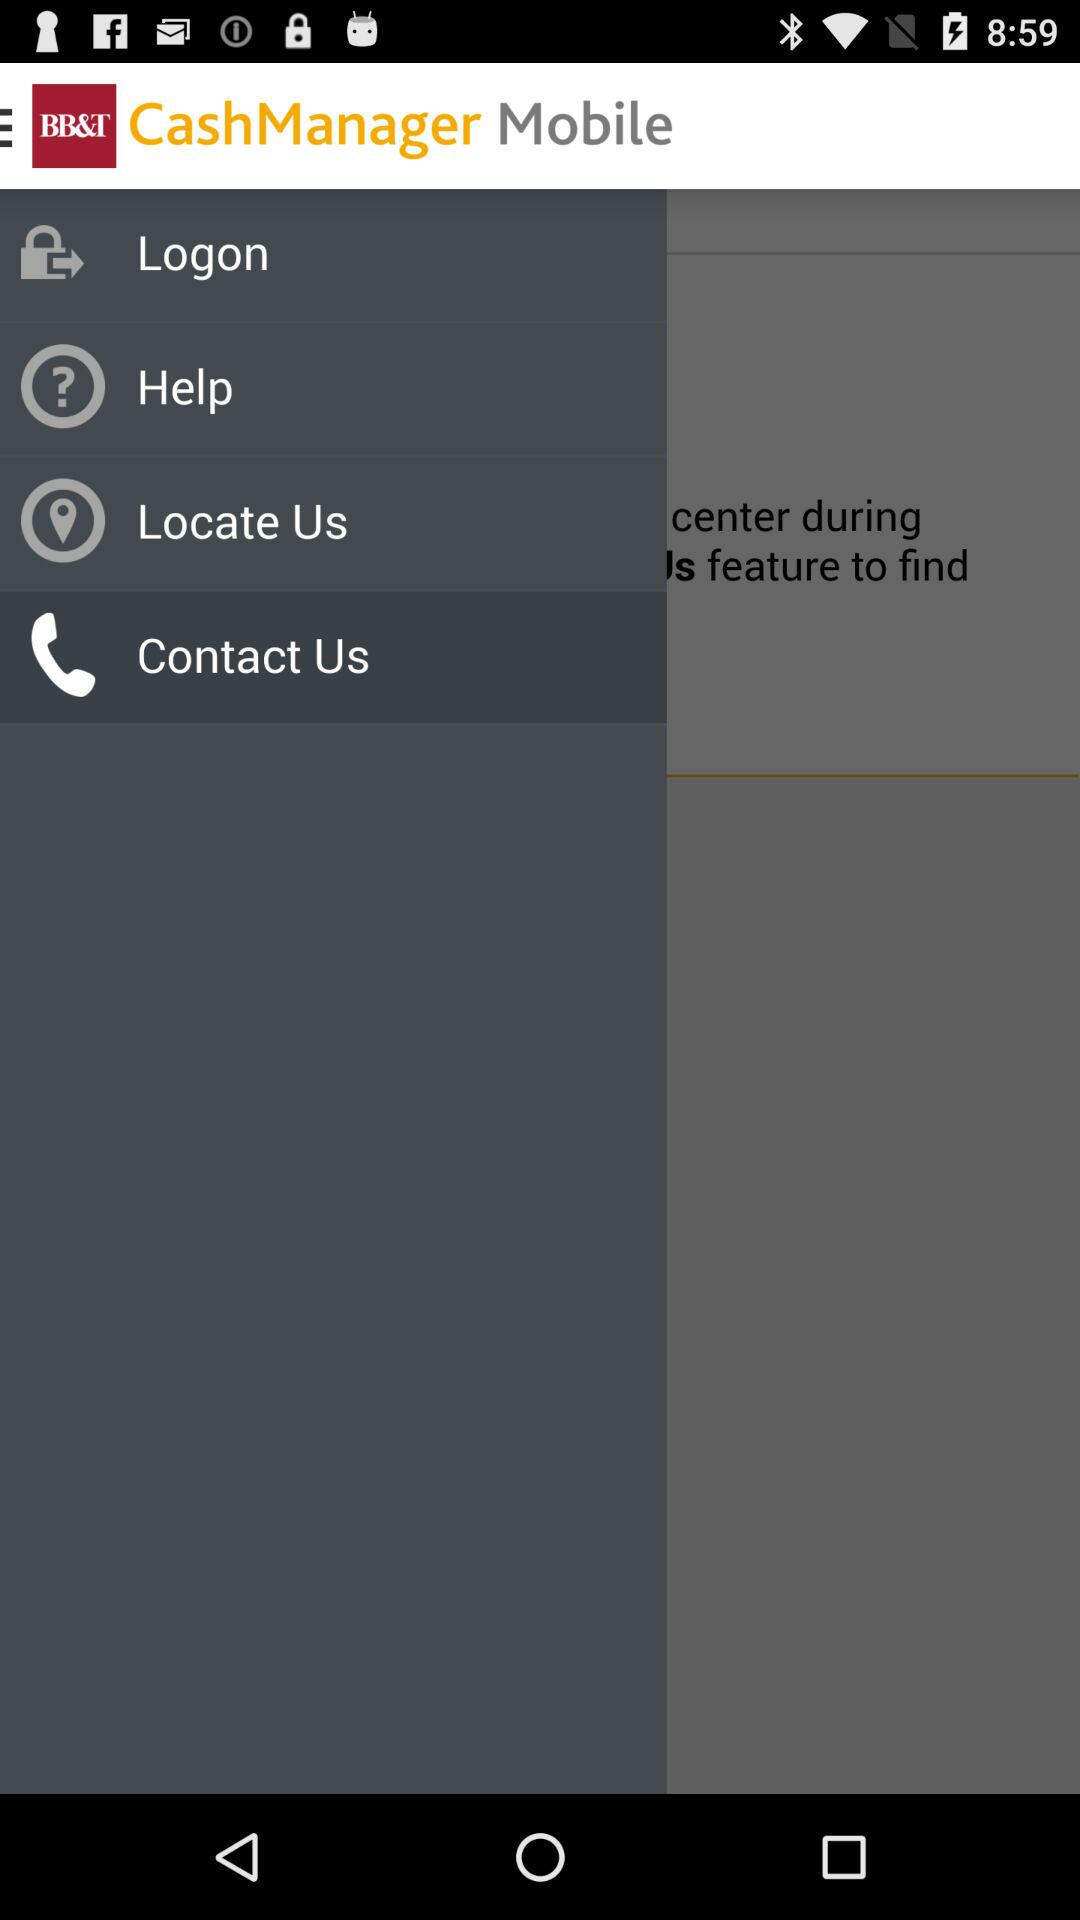What's the selected item in the menu? The selected item is "Contact Us". 